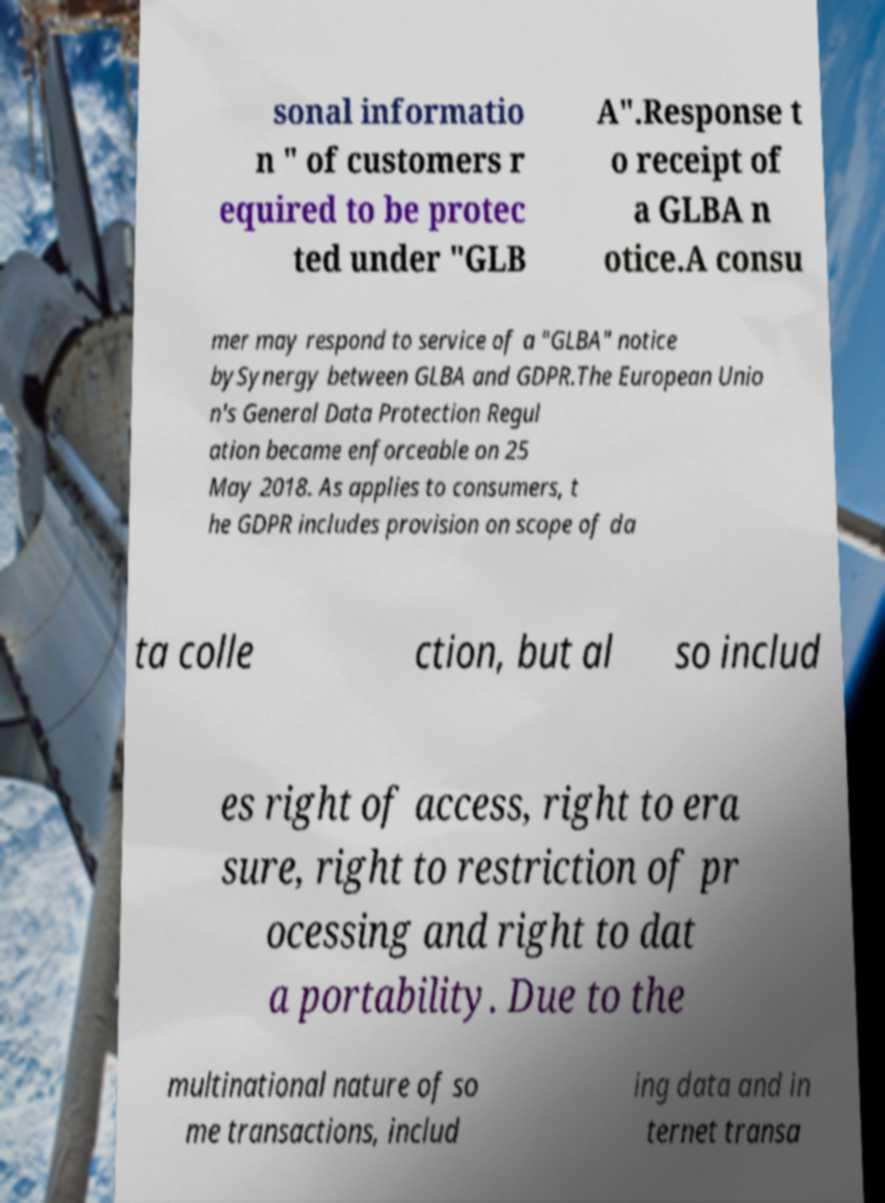What messages or text are displayed in this image? I need them in a readable, typed format. sonal informatio n " of customers r equired to be protec ted under "GLB A".Response t o receipt of a GLBA n otice.A consu mer may respond to service of a "GLBA" notice bySynergy between GLBA and GDPR.The European Unio n's General Data Protection Regul ation became enforceable on 25 May 2018. As applies to consumers, t he GDPR includes provision on scope of da ta colle ction, but al so includ es right of access, right to era sure, right to restriction of pr ocessing and right to dat a portability. Due to the multinational nature of so me transactions, includ ing data and in ternet transa 